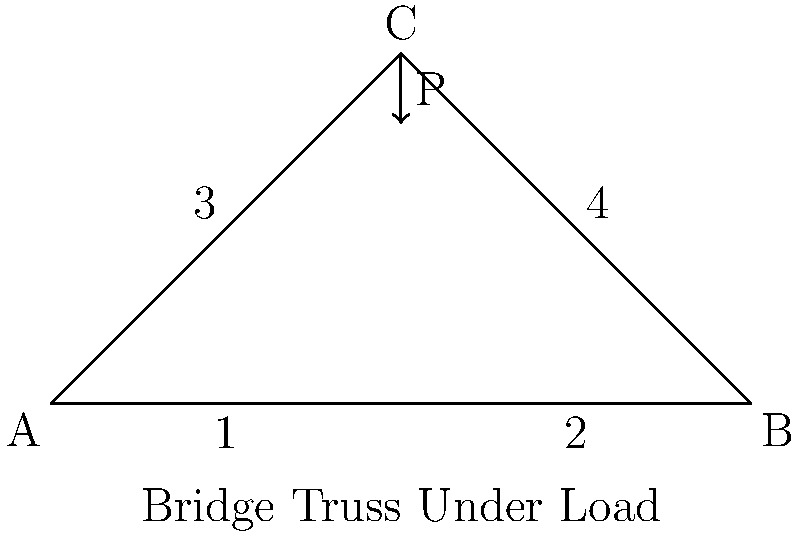In this controversial bridge design, which member of the truss experiences the highest compressive stress when a vertical load P is applied at joint C? Explain your reasoning using your edgy engineering intuition. Let's break this down with some bold engineering logic:

1. First, recognize that this is a simple triangular truss with three members.

2. When load P is applied vertically at joint C, it creates a compression force in members 3 and 4.

3. Members 1 and 2 experience tension to balance the horizontal components of forces in members 3 and 4.

4. The vertical components of forces in members 3 and 4 balance the applied load P.

5. Due to symmetry, members 3 and 4 carry equal forces.

6. The angle between members 3 and 4 is less than 90°, which means they're more vertical than horizontal.

7. As a result, the compressive force in members 3 and 4 will be greater than the applied load P.

8. Members 1 and 2 only experience tension, not compression.

Therefore, members 3 and 4 experience the highest compressive stress. They're the real MVPs of this edgy design, taking on the most stress like a boss!

To quantify this:

Let $\theta$ be the angle between members 3 or 4 and the horizontal.

$\tan \theta = \frac{50}{50} = 1$, so $\theta = 45°$

Force in member 3 or 4 = $F = \frac{P}{2 \cos 45°} = \frac{P}{\sqrt{2}} \approx 0.707P$

This is indeed greater than P, confirming our intuition.
Answer: Members 3 and 4 